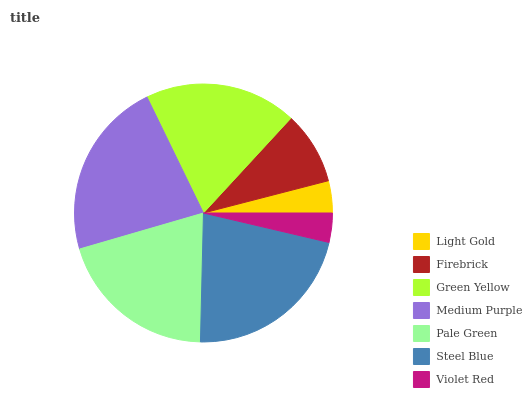Is Violet Red the minimum?
Answer yes or no. Yes. Is Medium Purple the maximum?
Answer yes or no. Yes. Is Firebrick the minimum?
Answer yes or no. No. Is Firebrick the maximum?
Answer yes or no. No. Is Firebrick greater than Light Gold?
Answer yes or no. Yes. Is Light Gold less than Firebrick?
Answer yes or no. Yes. Is Light Gold greater than Firebrick?
Answer yes or no. No. Is Firebrick less than Light Gold?
Answer yes or no. No. Is Green Yellow the high median?
Answer yes or no. Yes. Is Green Yellow the low median?
Answer yes or no. Yes. Is Light Gold the high median?
Answer yes or no. No. Is Steel Blue the low median?
Answer yes or no. No. 